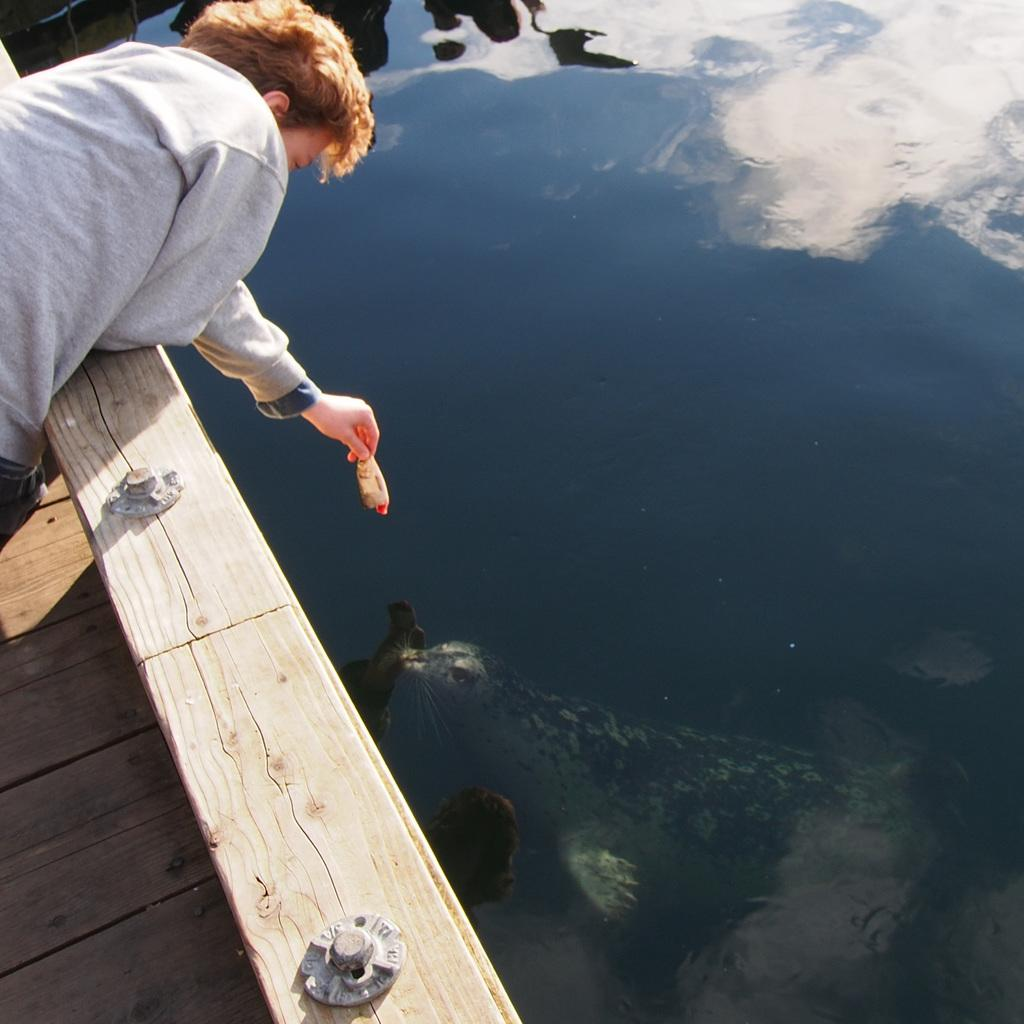Who is present in the image? There is a man in the image. What is the man holding in the image? The man is holding a fish. What can be seen in the background of the image? There is water visible in the image. What type of animal can be seen in the water? There is an aquatic animal in the water. What kind of structure is present in the image? There appears to be a wooden bridge in the image. What scent can be detected coming from the man's head in the image? There is no mention of a scent or the man's head in the image, so it cannot be determined. 